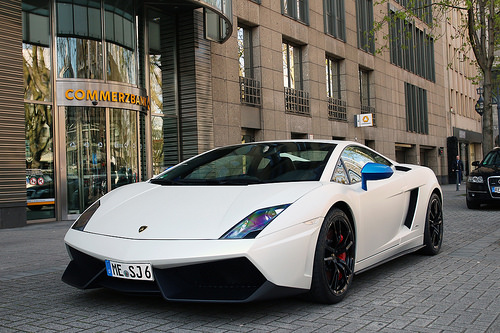<image>
Is the car in front of the door? No. The car is not in front of the door. The spatial positioning shows a different relationship between these objects. 